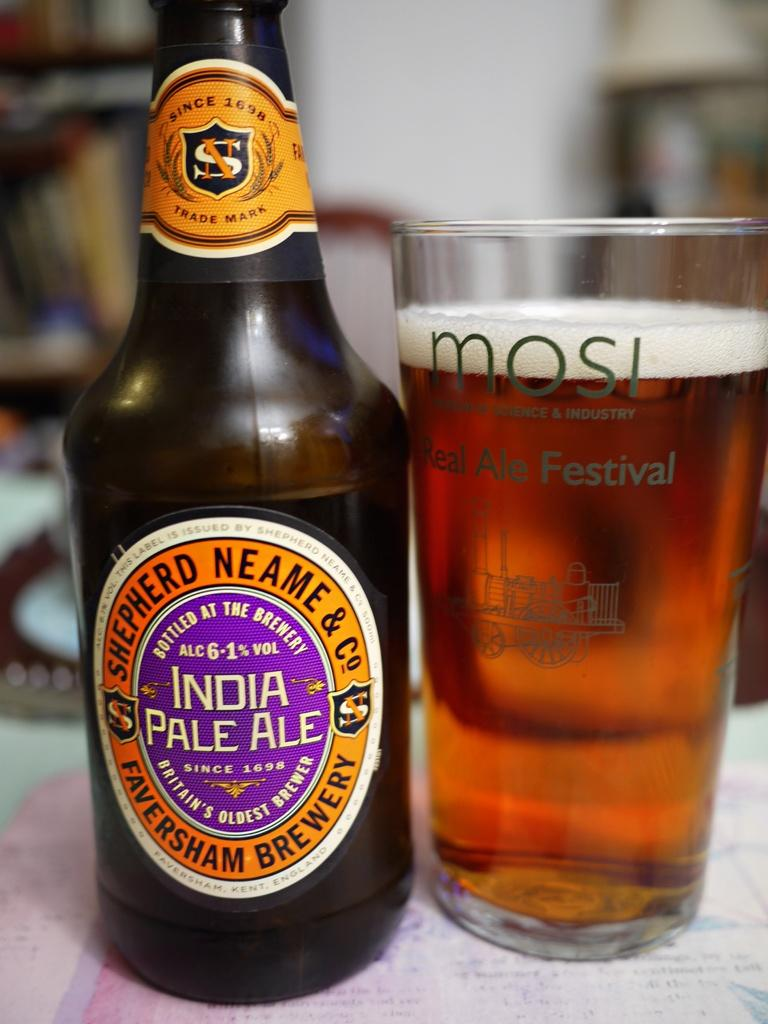<image>
Share a concise interpretation of the image provided. A bottle of India Pale Ale next to a full bear glass from the Mosi Museum of Science and Industry. 